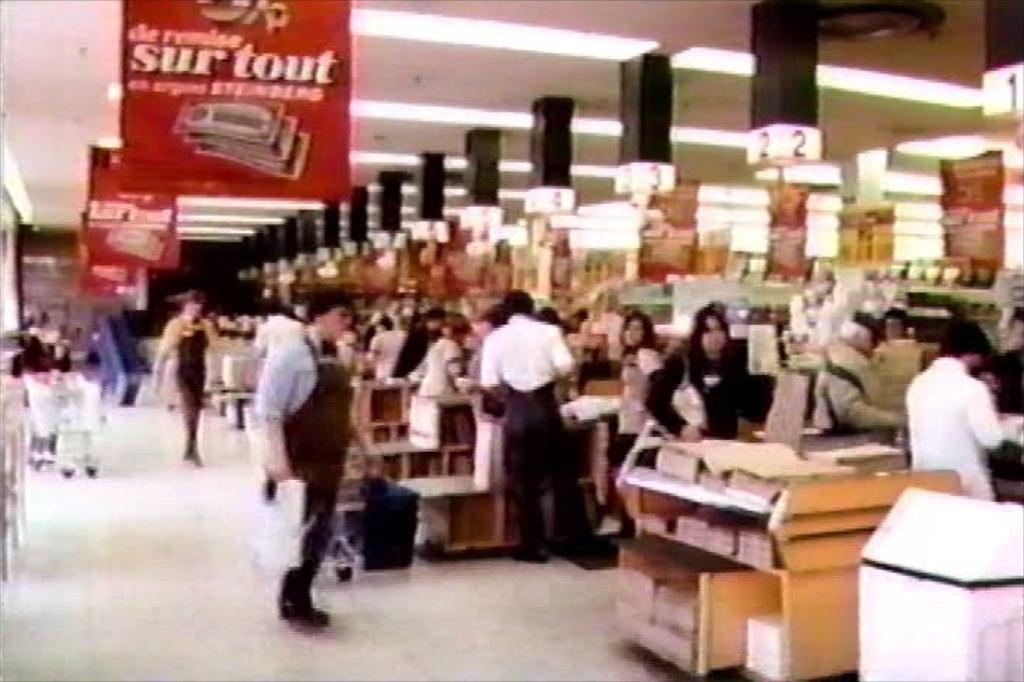Describe this image in one or two sentences. In this image I can see the blurry picture in which I can see the floor, few persons standing, few trolleys, few wooden tables with few objects on them, the ceiling, few lights to the ceiling, few red colored banners to the ceiling and black colored poles attached to the ceiling. 